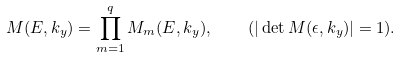Convert formula to latex. <formula><loc_0><loc_0><loc_500><loc_500>M ( E , k _ { y } ) = \prod _ { m = 1 } ^ { q } M _ { m } ( E , k _ { y } ) , \quad ( | \det M ( \epsilon , k _ { y } ) | = 1 ) .</formula> 